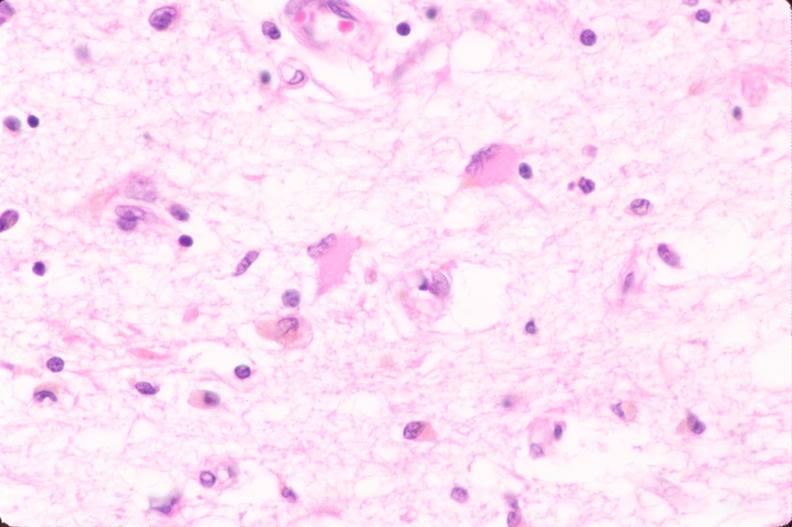s schwannoma present?
Answer the question using a single word or phrase. No 